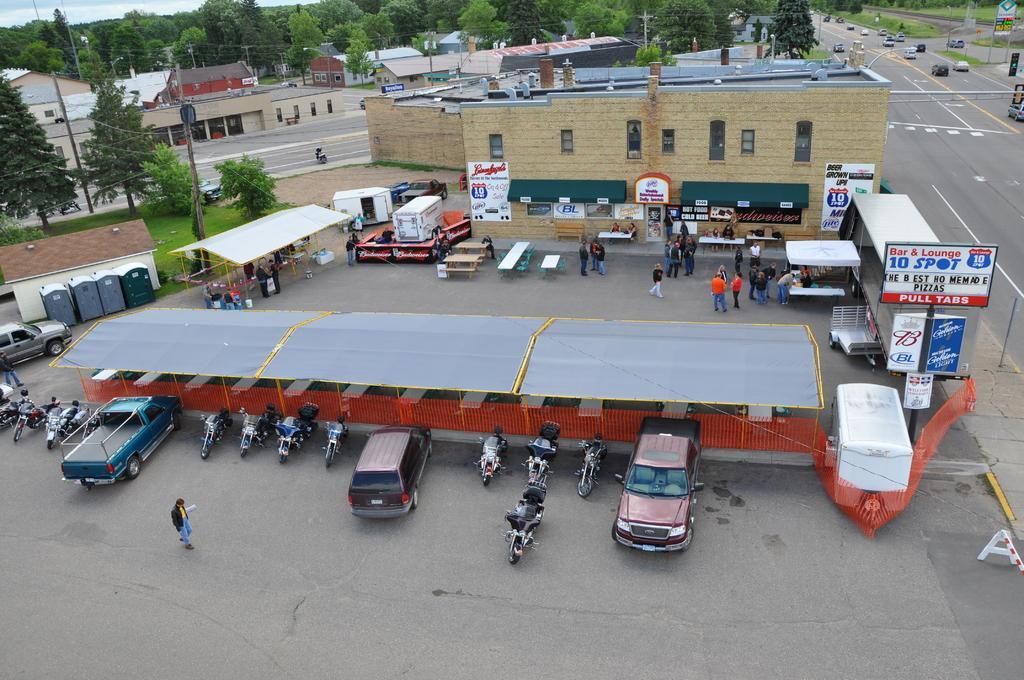Please provide a concise description of this image. In the center of the image there are buildings and trees. At the bottom there are sheds, cars, bikes and a van. We can see people standing. On the right there is a road and we can see boards. At the top there is sky. 